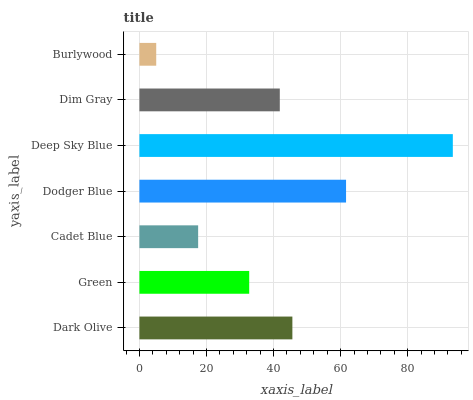Is Burlywood the minimum?
Answer yes or no. Yes. Is Deep Sky Blue the maximum?
Answer yes or no. Yes. Is Green the minimum?
Answer yes or no. No. Is Green the maximum?
Answer yes or no. No. Is Dark Olive greater than Green?
Answer yes or no. Yes. Is Green less than Dark Olive?
Answer yes or no. Yes. Is Green greater than Dark Olive?
Answer yes or no. No. Is Dark Olive less than Green?
Answer yes or no. No. Is Dim Gray the high median?
Answer yes or no. Yes. Is Dim Gray the low median?
Answer yes or no. Yes. Is Green the high median?
Answer yes or no. No. Is Cadet Blue the low median?
Answer yes or no. No. 